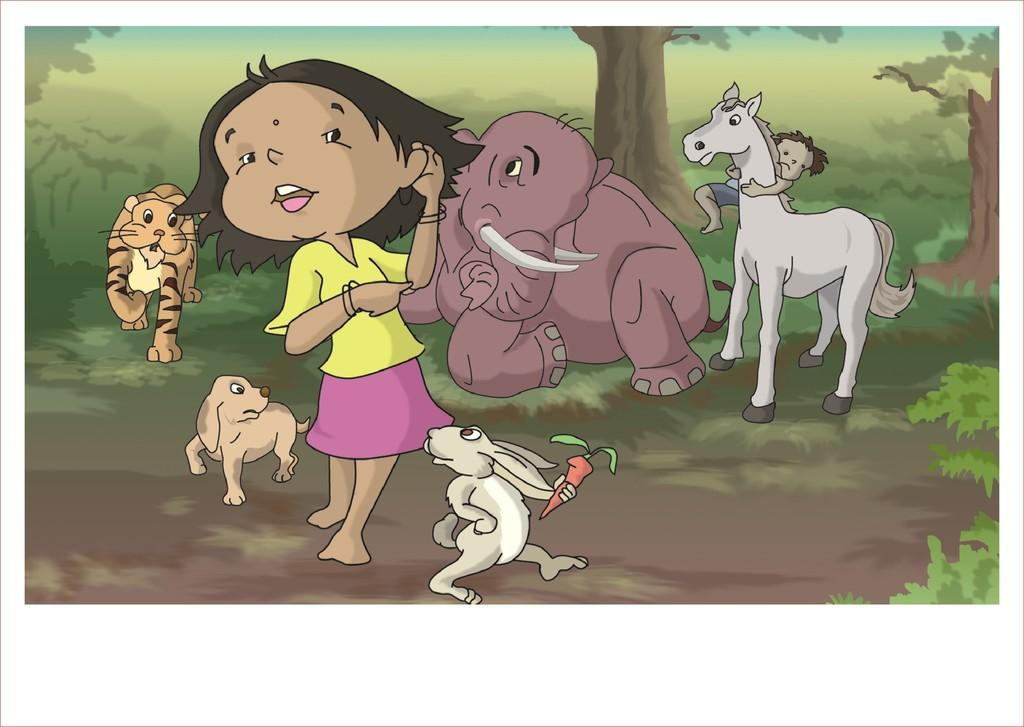What style is the image drawn in? The image is a cartoon. What types of living beings can be seen in the image? There are animals and people present in the image. What elements of nature are depicted in the image? There are plants and trees in the image. What is the temperature of the steam coming from the trees in the image? There is no steam present in the image; it features a cartoon with animals, people, plants, and trees. 